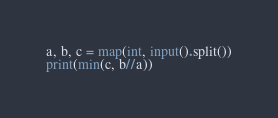Convert code to text. <code><loc_0><loc_0><loc_500><loc_500><_Python_>a, b, c = map(int, input().split())
print(min(c, b//a))</code> 